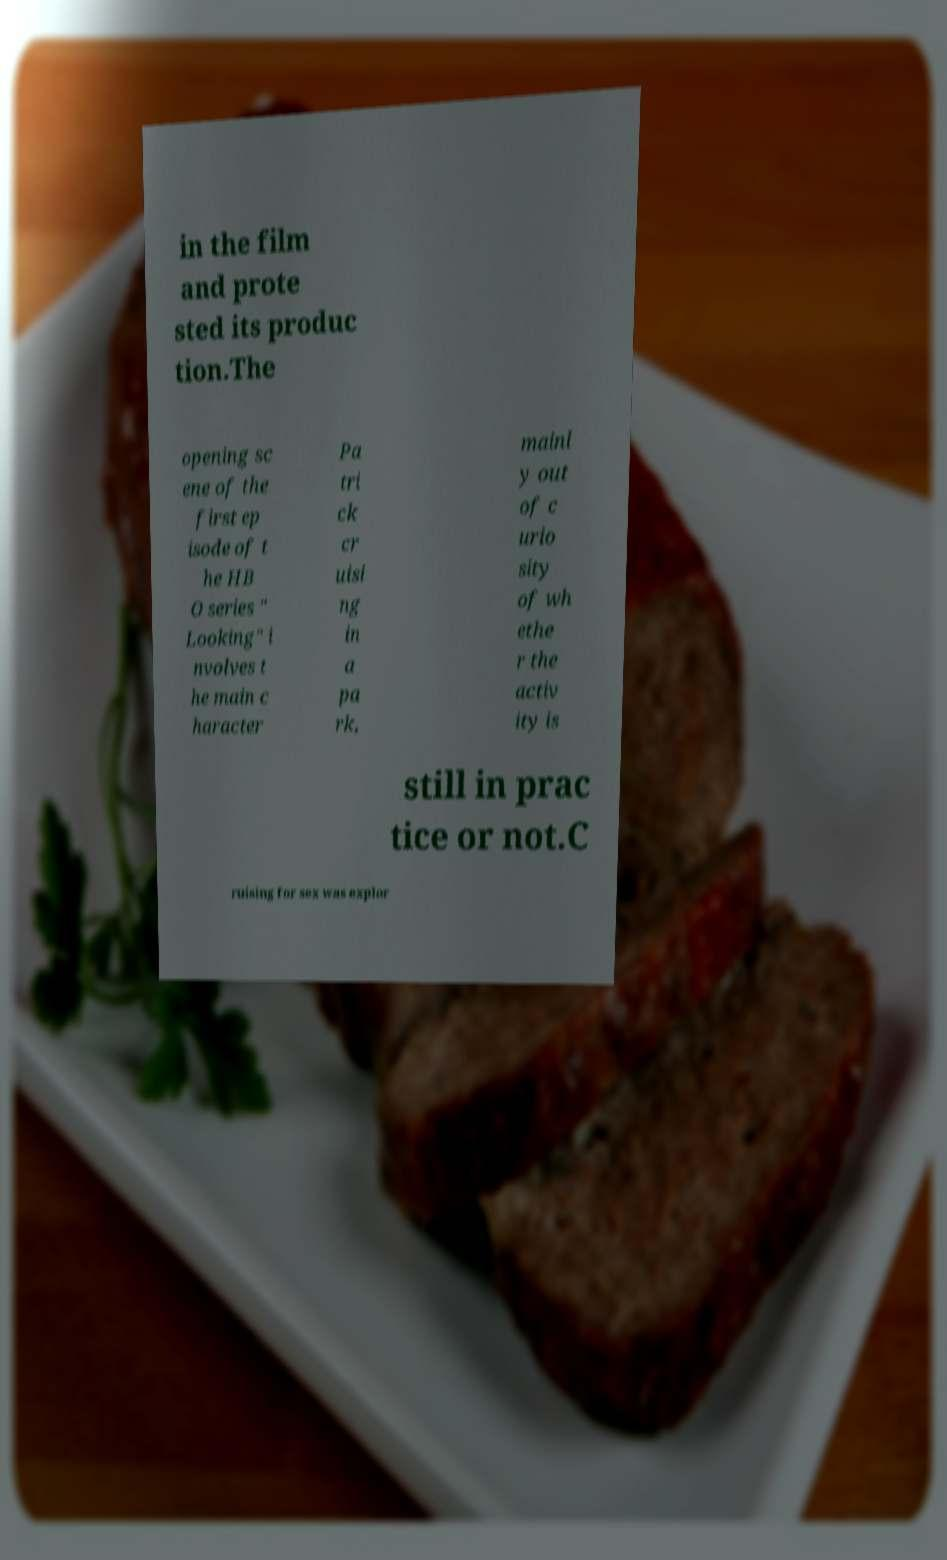Please read and relay the text visible in this image. What does it say? in the film and prote sted its produc tion.The opening sc ene of the first ep isode of t he HB O series " Looking" i nvolves t he main c haracter Pa tri ck cr uisi ng in a pa rk, mainl y out of c urio sity of wh ethe r the activ ity is still in prac tice or not.C ruising for sex was explor 